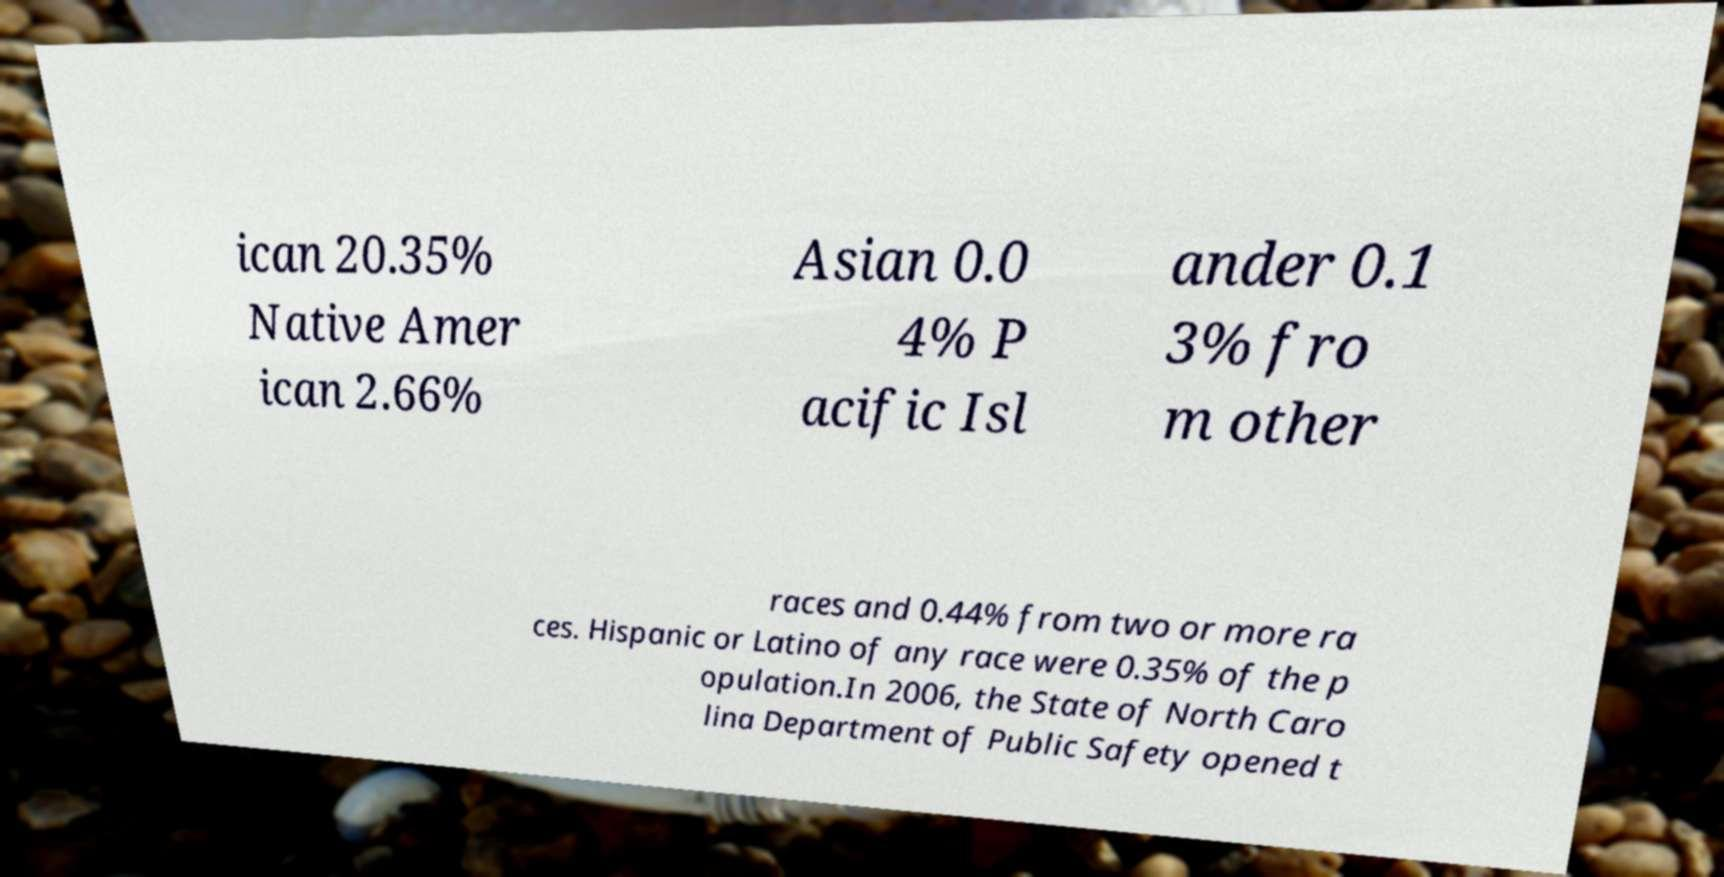Can you accurately transcribe the text from the provided image for me? ican 20.35% Native Amer ican 2.66% Asian 0.0 4% P acific Isl ander 0.1 3% fro m other races and 0.44% from two or more ra ces. Hispanic or Latino of any race were 0.35% of the p opulation.In 2006, the State of North Caro lina Department of Public Safety opened t 